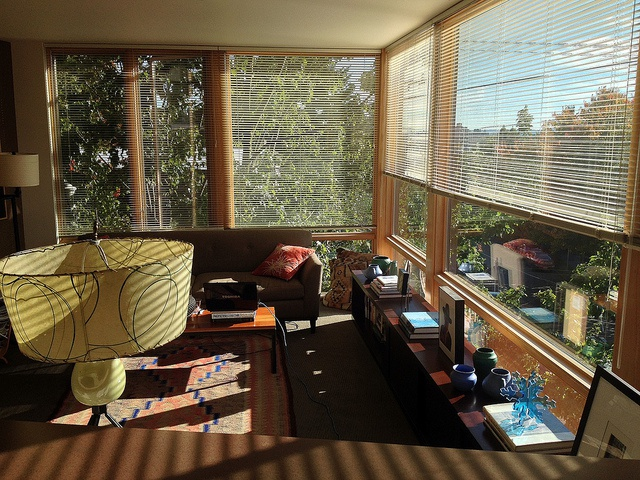Describe the objects in this image and their specific colors. I can see couch in black, maroon, and tan tones, book in black, ivory, and gray tones, laptop in black, maroon, and gray tones, car in black, maroon, and brown tones, and book in black, lightblue, and gray tones in this image. 